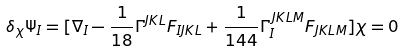<formula> <loc_0><loc_0><loc_500><loc_500>\delta _ { \chi } { \Psi } _ { I } = [ \nabla _ { I } - { \frac { 1 } { 1 8 } } \Gamma ^ { J K L } F _ { I J K L } + \frac { 1 } { 1 4 4 } \Gamma _ { I } ^ { \, J K L M } F _ { J K L M } ] \chi = 0</formula> 